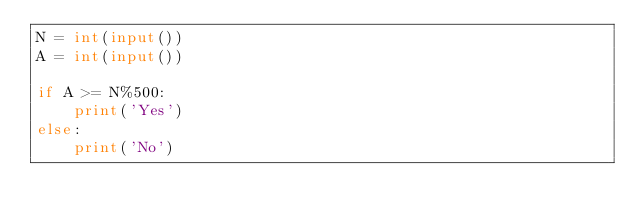<code> <loc_0><loc_0><loc_500><loc_500><_Python_>N = int(input())
A = int(input())

if A >= N%500:
    print('Yes')
else:
    print('No')</code> 